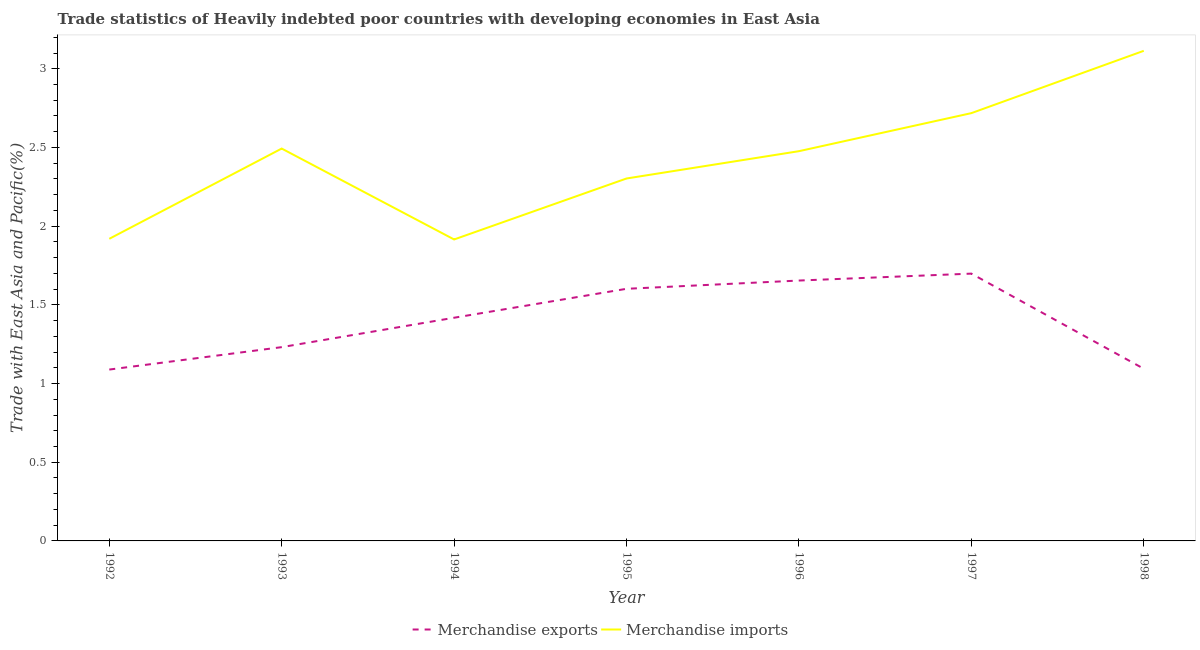Does the line corresponding to merchandise imports intersect with the line corresponding to merchandise exports?
Ensure brevity in your answer.  No. Is the number of lines equal to the number of legend labels?
Provide a short and direct response. Yes. What is the merchandise exports in 1994?
Keep it short and to the point. 1.42. Across all years, what is the maximum merchandise imports?
Provide a short and direct response. 3.11. Across all years, what is the minimum merchandise exports?
Make the answer very short. 1.09. In which year was the merchandise imports maximum?
Your answer should be very brief. 1998. In which year was the merchandise imports minimum?
Your answer should be very brief. 1994. What is the total merchandise imports in the graph?
Your answer should be compact. 16.94. What is the difference between the merchandise imports in 1992 and that in 1997?
Provide a short and direct response. -0.8. What is the difference between the merchandise imports in 1997 and the merchandise exports in 1995?
Your response must be concise. 1.12. What is the average merchandise imports per year?
Make the answer very short. 2.42. In the year 1992, what is the difference between the merchandise exports and merchandise imports?
Provide a short and direct response. -0.83. What is the ratio of the merchandise imports in 1994 to that in 1997?
Make the answer very short. 0.7. What is the difference between the highest and the second highest merchandise exports?
Your response must be concise. 0.04. What is the difference between the highest and the lowest merchandise imports?
Your answer should be very brief. 1.2. Does the merchandise exports monotonically increase over the years?
Give a very brief answer. No. Is the merchandise imports strictly greater than the merchandise exports over the years?
Give a very brief answer. Yes. Is the merchandise imports strictly less than the merchandise exports over the years?
Provide a short and direct response. No. How many lines are there?
Your response must be concise. 2. How many years are there in the graph?
Ensure brevity in your answer.  7. What is the difference between two consecutive major ticks on the Y-axis?
Your response must be concise. 0.5. Are the values on the major ticks of Y-axis written in scientific E-notation?
Your answer should be compact. No. Does the graph contain grids?
Offer a terse response. No. Where does the legend appear in the graph?
Make the answer very short. Bottom center. How many legend labels are there?
Offer a very short reply. 2. What is the title of the graph?
Keep it short and to the point. Trade statistics of Heavily indebted poor countries with developing economies in East Asia. Does "Automatic Teller Machines" appear as one of the legend labels in the graph?
Give a very brief answer. No. What is the label or title of the Y-axis?
Your answer should be compact. Trade with East Asia and Pacific(%). What is the Trade with East Asia and Pacific(%) of Merchandise exports in 1992?
Ensure brevity in your answer.  1.09. What is the Trade with East Asia and Pacific(%) in Merchandise imports in 1992?
Ensure brevity in your answer.  1.92. What is the Trade with East Asia and Pacific(%) in Merchandise exports in 1993?
Keep it short and to the point. 1.23. What is the Trade with East Asia and Pacific(%) in Merchandise imports in 1993?
Keep it short and to the point. 2.49. What is the Trade with East Asia and Pacific(%) in Merchandise exports in 1994?
Keep it short and to the point. 1.42. What is the Trade with East Asia and Pacific(%) in Merchandise imports in 1994?
Ensure brevity in your answer.  1.92. What is the Trade with East Asia and Pacific(%) of Merchandise exports in 1995?
Provide a succinct answer. 1.6. What is the Trade with East Asia and Pacific(%) in Merchandise imports in 1995?
Keep it short and to the point. 2.3. What is the Trade with East Asia and Pacific(%) of Merchandise exports in 1996?
Provide a succinct answer. 1.65. What is the Trade with East Asia and Pacific(%) in Merchandise imports in 1996?
Your answer should be compact. 2.48. What is the Trade with East Asia and Pacific(%) of Merchandise exports in 1997?
Offer a very short reply. 1.7. What is the Trade with East Asia and Pacific(%) in Merchandise imports in 1997?
Provide a short and direct response. 2.72. What is the Trade with East Asia and Pacific(%) in Merchandise exports in 1998?
Your answer should be very brief. 1.09. What is the Trade with East Asia and Pacific(%) in Merchandise imports in 1998?
Offer a very short reply. 3.11. Across all years, what is the maximum Trade with East Asia and Pacific(%) of Merchandise exports?
Your answer should be very brief. 1.7. Across all years, what is the maximum Trade with East Asia and Pacific(%) of Merchandise imports?
Your response must be concise. 3.11. Across all years, what is the minimum Trade with East Asia and Pacific(%) in Merchandise exports?
Provide a succinct answer. 1.09. Across all years, what is the minimum Trade with East Asia and Pacific(%) in Merchandise imports?
Ensure brevity in your answer.  1.92. What is the total Trade with East Asia and Pacific(%) of Merchandise exports in the graph?
Make the answer very short. 9.79. What is the total Trade with East Asia and Pacific(%) in Merchandise imports in the graph?
Your response must be concise. 16.94. What is the difference between the Trade with East Asia and Pacific(%) of Merchandise exports in 1992 and that in 1993?
Provide a short and direct response. -0.14. What is the difference between the Trade with East Asia and Pacific(%) in Merchandise imports in 1992 and that in 1993?
Ensure brevity in your answer.  -0.57. What is the difference between the Trade with East Asia and Pacific(%) of Merchandise exports in 1992 and that in 1994?
Your response must be concise. -0.33. What is the difference between the Trade with East Asia and Pacific(%) in Merchandise imports in 1992 and that in 1994?
Your response must be concise. 0. What is the difference between the Trade with East Asia and Pacific(%) in Merchandise exports in 1992 and that in 1995?
Offer a very short reply. -0.51. What is the difference between the Trade with East Asia and Pacific(%) of Merchandise imports in 1992 and that in 1995?
Keep it short and to the point. -0.38. What is the difference between the Trade with East Asia and Pacific(%) of Merchandise exports in 1992 and that in 1996?
Give a very brief answer. -0.57. What is the difference between the Trade with East Asia and Pacific(%) in Merchandise imports in 1992 and that in 1996?
Your response must be concise. -0.56. What is the difference between the Trade with East Asia and Pacific(%) in Merchandise exports in 1992 and that in 1997?
Your response must be concise. -0.61. What is the difference between the Trade with East Asia and Pacific(%) in Merchandise imports in 1992 and that in 1997?
Your answer should be compact. -0.8. What is the difference between the Trade with East Asia and Pacific(%) of Merchandise exports in 1992 and that in 1998?
Keep it short and to the point. -0.01. What is the difference between the Trade with East Asia and Pacific(%) in Merchandise imports in 1992 and that in 1998?
Your answer should be compact. -1.19. What is the difference between the Trade with East Asia and Pacific(%) of Merchandise exports in 1993 and that in 1994?
Ensure brevity in your answer.  -0.19. What is the difference between the Trade with East Asia and Pacific(%) in Merchandise imports in 1993 and that in 1994?
Ensure brevity in your answer.  0.58. What is the difference between the Trade with East Asia and Pacific(%) in Merchandise exports in 1993 and that in 1995?
Make the answer very short. -0.37. What is the difference between the Trade with East Asia and Pacific(%) in Merchandise imports in 1993 and that in 1995?
Provide a succinct answer. 0.19. What is the difference between the Trade with East Asia and Pacific(%) in Merchandise exports in 1993 and that in 1996?
Your answer should be very brief. -0.42. What is the difference between the Trade with East Asia and Pacific(%) of Merchandise imports in 1993 and that in 1996?
Give a very brief answer. 0.02. What is the difference between the Trade with East Asia and Pacific(%) in Merchandise exports in 1993 and that in 1997?
Offer a very short reply. -0.47. What is the difference between the Trade with East Asia and Pacific(%) in Merchandise imports in 1993 and that in 1997?
Make the answer very short. -0.23. What is the difference between the Trade with East Asia and Pacific(%) of Merchandise exports in 1993 and that in 1998?
Offer a terse response. 0.14. What is the difference between the Trade with East Asia and Pacific(%) of Merchandise imports in 1993 and that in 1998?
Give a very brief answer. -0.62. What is the difference between the Trade with East Asia and Pacific(%) in Merchandise exports in 1994 and that in 1995?
Your response must be concise. -0.18. What is the difference between the Trade with East Asia and Pacific(%) of Merchandise imports in 1994 and that in 1995?
Ensure brevity in your answer.  -0.39. What is the difference between the Trade with East Asia and Pacific(%) of Merchandise exports in 1994 and that in 1996?
Make the answer very short. -0.24. What is the difference between the Trade with East Asia and Pacific(%) in Merchandise imports in 1994 and that in 1996?
Give a very brief answer. -0.56. What is the difference between the Trade with East Asia and Pacific(%) of Merchandise exports in 1994 and that in 1997?
Your response must be concise. -0.28. What is the difference between the Trade with East Asia and Pacific(%) in Merchandise imports in 1994 and that in 1997?
Provide a short and direct response. -0.8. What is the difference between the Trade with East Asia and Pacific(%) of Merchandise exports in 1994 and that in 1998?
Ensure brevity in your answer.  0.32. What is the difference between the Trade with East Asia and Pacific(%) of Merchandise imports in 1994 and that in 1998?
Provide a short and direct response. -1.2. What is the difference between the Trade with East Asia and Pacific(%) of Merchandise exports in 1995 and that in 1996?
Offer a terse response. -0.05. What is the difference between the Trade with East Asia and Pacific(%) of Merchandise imports in 1995 and that in 1996?
Provide a succinct answer. -0.17. What is the difference between the Trade with East Asia and Pacific(%) of Merchandise exports in 1995 and that in 1997?
Give a very brief answer. -0.1. What is the difference between the Trade with East Asia and Pacific(%) in Merchandise imports in 1995 and that in 1997?
Provide a short and direct response. -0.42. What is the difference between the Trade with East Asia and Pacific(%) in Merchandise exports in 1995 and that in 1998?
Keep it short and to the point. 0.51. What is the difference between the Trade with East Asia and Pacific(%) of Merchandise imports in 1995 and that in 1998?
Offer a terse response. -0.81. What is the difference between the Trade with East Asia and Pacific(%) in Merchandise exports in 1996 and that in 1997?
Keep it short and to the point. -0.04. What is the difference between the Trade with East Asia and Pacific(%) of Merchandise imports in 1996 and that in 1997?
Provide a succinct answer. -0.24. What is the difference between the Trade with East Asia and Pacific(%) in Merchandise exports in 1996 and that in 1998?
Your response must be concise. 0.56. What is the difference between the Trade with East Asia and Pacific(%) in Merchandise imports in 1996 and that in 1998?
Provide a succinct answer. -0.64. What is the difference between the Trade with East Asia and Pacific(%) in Merchandise exports in 1997 and that in 1998?
Keep it short and to the point. 0.6. What is the difference between the Trade with East Asia and Pacific(%) in Merchandise imports in 1997 and that in 1998?
Your answer should be very brief. -0.4. What is the difference between the Trade with East Asia and Pacific(%) in Merchandise exports in 1992 and the Trade with East Asia and Pacific(%) in Merchandise imports in 1993?
Provide a succinct answer. -1.4. What is the difference between the Trade with East Asia and Pacific(%) of Merchandise exports in 1992 and the Trade with East Asia and Pacific(%) of Merchandise imports in 1994?
Provide a short and direct response. -0.83. What is the difference between the Trade with East Asia and Pacific(%) in Merchandise exports in 1992 and the Trade with East Asia and Pacific(%) in Merchandise imports in 1995?
Your answer should be very brief. -1.21. What is the difference between the Trade with East Asia and Pacific(%) in Merchandise exports in 1992 and the Trade with East Asia and Pacific(%) in Merchandise imports in 1996?
Your answer should be compact. -1.39. What is the difference between the Trade with East Asia and Pacific(%) of Merchandise exports in 1992 and the Trade with East Asia and Pacific(%) of Merchandise imports in 1997?
Your response must be concise. -1.63. What is the difference between the Trade with East Asia and Pacific(%) of Merchandise exports in 1992 and the Trade with East Asia and Pacific(%) of Merchandise imports in 1998?
Offer a terse response. -2.03. What is the difference between the Trade with East Asia and Pacific(%) of Merchandise exports in 1993 and the Trade with East Asia and Pacific(%) of Merchandise imports in 1994?
Offer a very short reply. -0.68. What is the difference between the Trade with East Asia and Pacific(%) of Merchandise exports in 1993 and the Trade with East Asia and Pacific(%) of Merchandise imports in 1995?
Offer a terse response. -1.07. What is the difference between the Trade with East Asia and Pacific(%) in Merchandise exports in 1993 and the Trade with East Asia and Pacific(%) in Merchandise imports in 1996?
Provide a succinct answer. -1.25. What is the difference between the Trade with East Asia and Pacific(%) in Merchandise exports in 1993 and the Trade with East Asia and Pacific(%) in Merchandise imports in 1997?
Your answer should be compact. -1.49. What is the difference between the Trade with East Asia and Pacific(%) of Merchandise exports in 1993 and the Trade with East Asia and Pacific(%) of Merchandise imports in 1998?
Your response must be concise. -1.88. What is the difference between the Trade with East Asia and Pacific(%) in Merchandise exports in 1994 and the Trade with East Asia and Pacific(%) in Merchandise imports in 1995?
Make the answer very short. -0.88. What is the difference between the Trade with East Asia and Pacific(%) of Merchandise exports in 1994 and the Trade with East Asia and Pacific(%) of Merchandise imports in 1996?
Make the answer very short. -1.06. What is the difference between the Trade with East Asia and Pacific(%) of Merchandise exports in 1994 and the Trade with East Asia and Pacific(%) of Merchandise imports in 1998?
Give a very brief answer. -1.7. What is the difference between the Trade with East Asia and Pacific(%) of Merchandise exports in 1995 and the Trade with East Asia and Pacific(%) of Merchandise imports in 1996?
Your answer should be compact. -0.87. What is the difference between the Trade with East Asia and Pacific(%) in Merchandise exports in 1995 and the Trade with East Asia and Pacific(%) in Merchandise imports in 1997?
Make the answer very short. -1.12. What is the difference between the Trade with East Asia and Pacific(%) in Merchandise exports in 1995 and the Trade with East Asia and Pacific(%) in Merchandise imports in 1998?
Your answer should be compact. -1.51. What is the difference between the Trade with East Asia and Pacific(%) of Merchandise exports in 1996 and the Trade with East Asia and Pacific(%) of Merchandise imports in 1997?
Your answer should be compact. -1.06. What is the difference between the Trade with East Asia and Pacific(%) in Merchandise exports in 1996 and the Trade with East Asia and Pacific(%) in Merchandise imports in 1998?
Ensure brevity in your answer.  -1.46. What is the difference between the Trade with East Asia and Pacific(%) in Merchandise exports in 1997 and the Trade with East Asia and Pacific(%) in Merchandise imports in 1998?
Your response must be concise. -1.42. What is the average Trade with East Asia and Pacific(%) of Merchandise exports per year?
Make the answer very short. 1.4. What is the average Trade with East Asia and Pacific(%) of Merchandise imports per year?
Make the answer very short. 2.42. In the year 1992, what is the difference between the Trade with East Asia and Pacific(%) in Merchandise exports and Trade with East Asia and Pacific(%) in Merchandise imports?
Your answer should be very brief. -0.83. In the year 1993, what is the difference between the Trade with East Asia and Pacific(%) in Merchandise exports and Trade with East Asia and Pacific(%) in Merchandise imports?
Your response must be concise. -1.26. In the year 1994, what is the difference between the Trade with East Asia and Pacific(%) in Merchandise exports and Trade with East Asia and Pacific(%) in Merchandise imports?
Keep it short and to the point. -0.5. In the year 1995, what is the difference between the Trade with East Asia and Pacific(%) in Merchandise exports and Trade with East Asia and Pacific(%) in Merchandise imports?
Provide a succinct answer. -0.7. In the year 1996, what is the difference between the Trade with East Asia and Pacific(%) of Merchandise exports and Trade with East Asia and Pacific(%) of Merchandise imports?
Ensure brevity in your answer.  -0.82. In the year 1997, what is the difference between the Trade with East Asia and Pacific(%) of Merchandise exports and Trade with East Asia and Pacific(%) of Merchandise imports?
Provide a succinct answer. -1.02. In the year 1998, what is the difference between the Trade with East Asia and Pacific(%) of Merchandise exports and Trade with East Asia and Pacific(%) of Merchandise imports?
Ensure brevity in your answer.  -2.02. What is the ratio of the Trade with East Asia and Pacific(%) in Merchandise exports in 1992 to that in 1993?
Keep it short and to the point. 0.88. What is the ratio of the Trade with East Asia and Pacific(%) in Merchandise imports in 1992 to that in 1993?
Provide a short and direct response. 0.77. What is the ratio of the Trade with East Asia and Pacific(%) in Merchandise exports in 1992 to that in 1994?
Make the answer very short. 0.77. What is the ratio of the Trade with East Asia and Pacific(%) of Merchandise exports in 1992 to that in 1995?
Provide a succinct answer. 0.68. What is the ratio of the Trade with East Asia and Pacific(%) in Merchandise imports in 1992 to that in 1995?
Give a very brief answer. 0.83. What is the ratio of the Trade with East Asia and Pacific(%) of Merchandise exports in 1992 to that in 1996?
Your answer should be compact. 0.66. What is the ratio of the Trade with East Asia and Pacific(%) in Merchandise imports in 1992 to that in 1996?
Your answer should be very brief. 0.78. What is the ratio of the Trade with East Asia and Pacific(%) in Merchandise exports in 1992 to that in 1997?
Ensure brevity in your answer.  0.64. What is the ratio of the Trade with East Asia and Pacific(%) in Merchandise imports in 1992 to that in 1997?
Your response must be concise. 0.71. What is the ratio of the Trade with East Asia and Pacific(%) of Merchandise exports in 1992 to that in 1998?
Provide a succinct answer. 1. What is the ratio of the Trade with East Asia and Pacific(%) in Merchandise imports in 1992 to that in 1998?
Provide a succinct answer. 0.62. What is the ratio of the Trade with East Asia and Pacific(%) of Merchandise exports in 1993 to that in 1994?
Keep it short and to the point. 0.87. What is the ratio of the Trade with East Asia and Pacific(%) of Merchandise imports in 1993 to that in 1994?
Offer a terse response. 1.3. What is the ratio of the Trade with East Asia and Pacific(%) in Merchandise exports in 1993 to that in 1995?
Your answer should be very brief. 0.77. What is the ratio of the Trade with East Asia and Pacific(%) of Merchandise imports in 1993 to that in 1995?
Provide a short and direct response. 1.08. What is the ratio of the Trade with East Asia and Pacific(%) in Merchandise exports in 1993 to that in 1996?
Keep it short and to the point. 0.74. What is the ratio of the Trade with East Asia and Pacific(%) in Merchandise imports in 1993 to that in 1996?
Your answer should be compact. 1.01. What is the ratio of the Trade with East Asia and Pacific(%) in Merchandise exports in 1993 to that in 1997?
Your response must be concise. 0.72. What is the ratio of the Trade with East Asia and Pacific(%) of Merchandise imports in 1993 to that in 1997?
Provide a short and direct response. 0.92. What is the ratio of the Trade with East Asia and Pacific(%) in Merchandise exports in 1993 to that in 1998?
Your answer should be very brief. 1.13. What is the ratio of the Trade with East Asia and Pacific(%) in Merchandise imports in 1993 to that in 1998?
Keep it short and to the point. 0.8. What is the ratio of the Trade with East Asia and Pacific(%) in Merchandise exports in 1994 to that in 1995?
Offer a terse response. 0.89. What is the ratio of the Trade with East Asia and Pacific(%) of Merchandise imports in 1994 to that in 1995?
Keep it short and to the point. 0.83. What is the ratio of the Trade with East Asia and Pacific(%) in Merchandise exports in 1994 to that in 1996?
Your answer should be compact. 0.86. What is the ratio of the Trade with East Asia and Pacific(%) of Merchandise imports in 1994 to that in 1996?
Provide a short and direct response. 0.77. What is the ratio of the Trade with East Asia and Pacific(%) of Merchandise exports in 1994 to that in 1997?
Offer a very short reply. 0.83. What is the ratio of the Trade with East Asia and Pacific(%) of Merchandise imports in 1994 to that in 1997?
Your response must be concise. 0.7. What is the ratio of the Trade with East Asia and Pacific(%) in Merchandise exports in 1994 to that in 1998?
Your answer should be compact. 1.3. What is the ratio of the Trade with East Asia and Pacific(%) in Merchandise imports in 1994 to that in 1998?
Your response must be concise. 0.62. What is the ratio of the Trade with East Asia and Pacific(%) in Merchandise exports in 1995 to that in 1996?
Give a very brief answer. 0.97. What is the ratio of the Trade with East Asia and Pacific(%) in Merchandise imports in 1995 to that in 1996?
Offer a terse response. 0.93. What is the ratio of the Trade with East Asia and Pacific(%) in Merchandise exports in 1995 to that in 1997?
Ensure brevity in your answer.  0.94. What is the ratio of the Trade with East Asia and Pacific(%) in Merchandise imports in 1995 to that in 1997?
Offer a terse response. 0.85. What is the ratio of the Trade with East Asia and Pacific(%) in Merchandise exports in 1995 to that in 1998?
Provide a succinct answer. 1.46. What is the ratio of the Trade with East Asia and Pacific(%) in Merchandise imports in 1995 to that in 1998?
Provide a succinct answer. 0.74. What is the ratio of the Trade with East Asia and Pacific(%) in Merchandise exports in 1996 to that in 1997?
Ensure brevity in your answer.  0.97. What is the ratio of the Trade with East Asia and Pacific(%) in Merchandise imports in 1996 to that in 1997?
Provide a succinct answer. 0.91. What is the ratio of the Trade with East Asia and Pacific(%) in Merchandise exports in 1996 to that in 1998?
Your response must be concise. 1.51. What is the ratio of the Trade with East Asia and Pacific(%) of Merchandise imports in 1996 to that in 1998?
Provide a short and direct response. 0.8. What is the ratio of the Trade with East Asia and Pacific(%) in Merchandise exports in 1997 to that in 1998?
Provide a succinct answer. 1.55. What is the ratio of the Trade with East Asia and Pacific(%) of Merchandise imports in 1997 to that in 1998?
Offer a very short reply. 0.87. What is the difference between the highest and the second highest Trade with East Asia and Pacific(%) in Merchandise exports?
Your answer should be compact. 0.04. What is the difference between the highest and the second highest Trade with East Asia and Pacific(%) of Merchandise imports?
Ensure brevity in your answer.  0.4. What is the difference between the highest and the lowest Trade with East Asia and Pacific(%) of Merchandise exports?
Provide a succinct answer. 0.61. What is the difference between the highest and the lowest Trade with East Asia and Pacific(%) of Merchandise imports?
Make the answer very short. 1.2. 